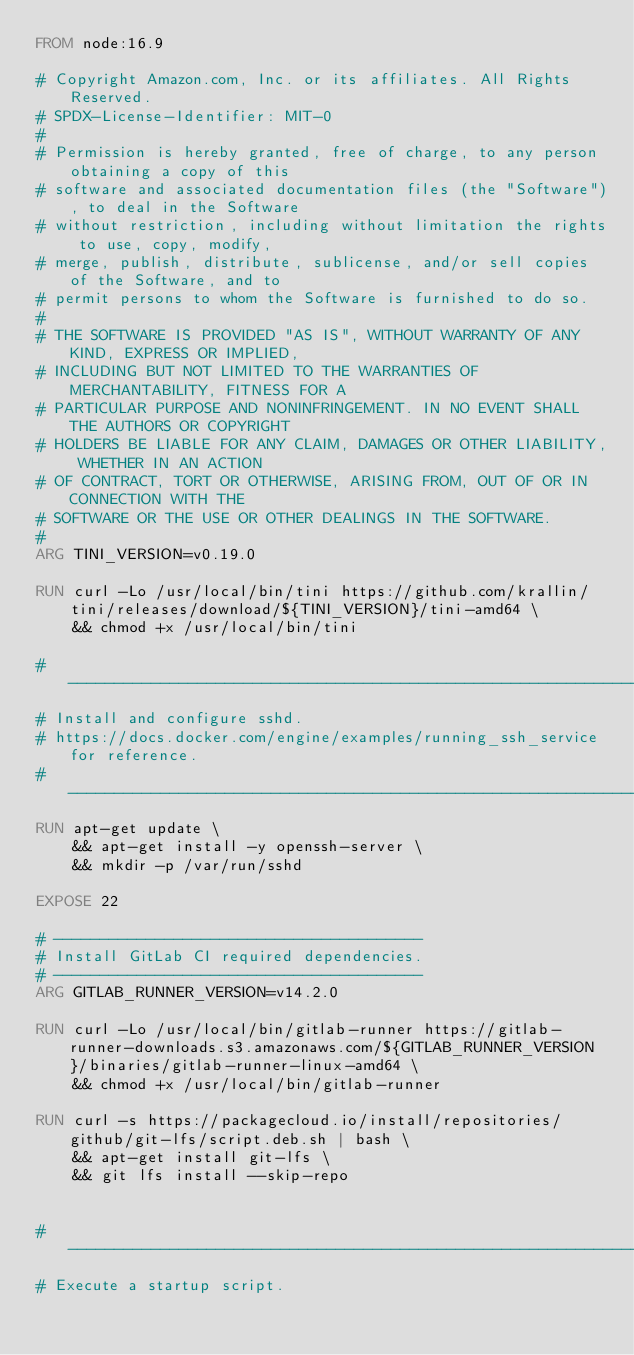Convert code to text. <code><loc_0><loc_0><loc_500><loc_500><_Dockerfile_>FROM node:16.9

# Copyright Amazon.com, Inc. or its affiliates. All Rights Reserved.
# SPDX-License-Identifier: MIT-0
#
# Permission is hereby granted, free of charge, to any person obtaining a copy of this
# software and associated documentation files (the "Software"), to deal in the Software
# without restriction, including without limitation the rights to use, copy, modify,
# merge, publish, distribute, sublicense, and/or sell copies of the Software, and to
# permit persons to whom the Software is furnished to do so.
#
# THE SOFTWARE IS PROVIDED "AS IS", WITHOUT WARRANTY OF ANY KIND, EXPRESS OR IMPLIED,
# INCLUDING BUT NOT LIMITED TO THE WARRANTIES OF MERCHANTABILITY, FITNESS FOR A
# PARTICULAR PURPOSE AND NONINFRINGEMENT. IN NO EVENT SHALL THE AUTHORS OR COPYRIGHT
# HOLDERS BE LIABLE FOR ANY CLAIM, DAMAGES OR OTHER LIABILITY, WHETHER IN AN ACTION
# OF CONTRACT, TORT OR OTHERWISE, ARISING FROM, OUT OF OR IN CONNECTION WITH THE
# SOFTWARE OR THE USE OR OTHER DEALINGS IN THE SOFTWARE.
#
ARG TINI_VERSION=v0.19.0

RUN curl -Lo /usr/local/bin/tini https://github.com/krallin/tini/releases/download/${TINI_VERSION}/tini-amd64 \
    && chmod +x /usr/local/bin/tini

# --------------------------------------------------------------------------
# Install and configure sshd.
# https://docs.docker.com/engine/examples/running_ssh_service for reference.
# --------------------------------------------------------------------------
RUN apt-get update \
    && apt-get install -y openssh-server \
    && mkdir -p /var/run/sshd

EXPOSE 22

# ----------------------------------------
# Install GitLab CI required dependencies.
# ----------------------------------------
ARG GITLAB_RUNNER_VERSION=v14.2.0

RUN curl -Lo /usr/local/bin/gitlab-runner https://gitlab-runner-downloads.s3.amazonaws.com/${GITLAB_RUNNER_VERSION}/binaries/gitlab-runner-linux-amd64 \
    && chmod +x /usr/local/bin/gitlab-runner

RUN curl -s https://packagecloud.io/install/repositories/github/git-lfs/script.deb.sh | bash \
    && apt-get install git-lfs \
    && git lfs install --skip-repo


# -------------------------------------------------------------------------------------
# Execute a startup script.</code> 